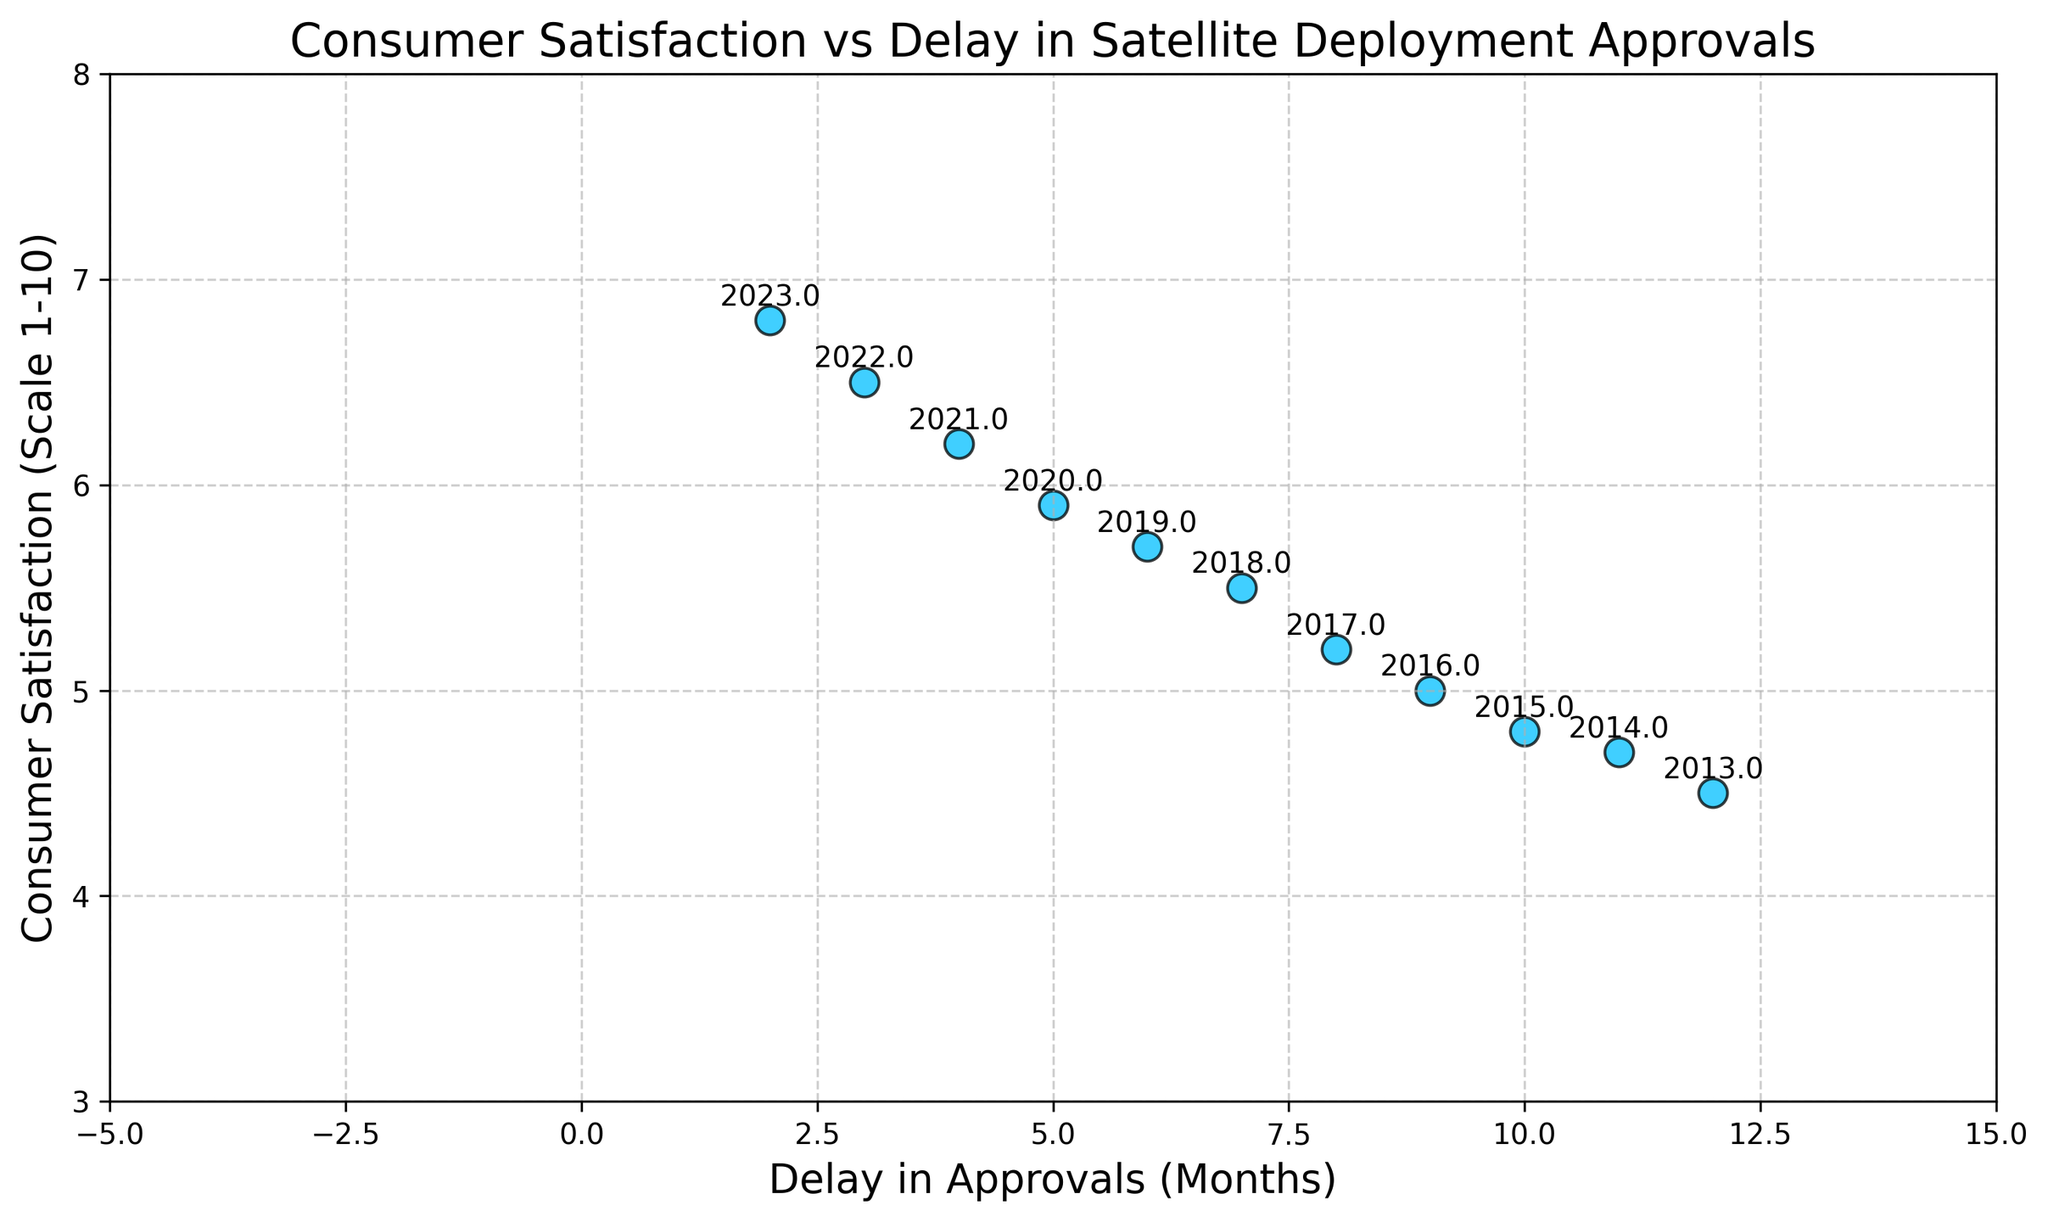What is the year with the highest Consumer Satisfaction rating shown on the plot? The plot has annotations indicating the year at each data point. The highest Consumer Satisfaction rating is around 6.8, which is annotated as the year 2023.
Answer: 2023 What is the delay in approvals for the year with the lowest Consumer Satisfaction rating? To identify the lowest Consumer Satisfaction rating, look for the smallest y-value. The lowest rating is 4.5, annotated as the year 2013. The x-value corresponding to 2013 is a delay of 12 months.
Answer: 12 months Which year's data point is closest to the y-axis in the plot? The y-axis represents zero delay in approvals. The data point closest to the y-axis has the smallest x-value, which is 2 months, annotated as the year 2023.
Answer: 2023 What is the trend observed in the Consumer Satisfaction ratings over the decade? To identify the trend, observe the change in y-values (Consumer Satisfaction) as the years progress. The y-values consistently increase, indicating a positive trend in Consumer Satisfaction ratings.
Answer: Positive trend How does the delay in approvals correlate with Consumer Satisfaction? The plot shows a negative slope, where higher delays are associated with lower Consumer Satisfaction ratings. This inverse relationship signifies that as delay in approvals decreases, Consumer Satisfaction increases.
Answer: Inverse correlation During which year did the Consumer Satisfaction first exceed 5.0? Check the data points where the y-value is greater than 5.0. The year 2016 shows a Consumer Satisfaction of 5.0, and 2017 exceeds 5.0 with a rating of 5.2.
Answer: 2017 What is the difference in delay of approvals between the highest and the lowest Consumer Satisfaction ratings? The highest satisfaction rating of 6.8 corresponds to a delay of 2 months (2023), and the lowest rating of 4.5 corresponds to 12 months (2013). The difference in delays is 12 - 2 = 10 months.
Answer: 10 months Which two consecutive years show the largest increase in Consumer Satisfaction ratings? Compare the year-over-year changes in Consumer Satisfaction ratings. The largest increase occurs between 2021 and 2022, where the rating increases from 6.2 to 6.5, a difference of 0.3.
Answer: 2021 to 2022 What is the average delay in approvals across all the years represented in the plot? Sum the delays over the years (12+11+10+9+8+7+6+5+4+3+2) = 77 months and divide by the number of data points (11). The average delay is 77 / 11 ≈ 7 months.
Answer: ~7 months In which year does the data point on the plot have the smallest y-coordinate? The y-coordinate represents Consumer Satisfaction. The year with the smallest value (4.5) is annotated as 2013.
Answer: 2013 